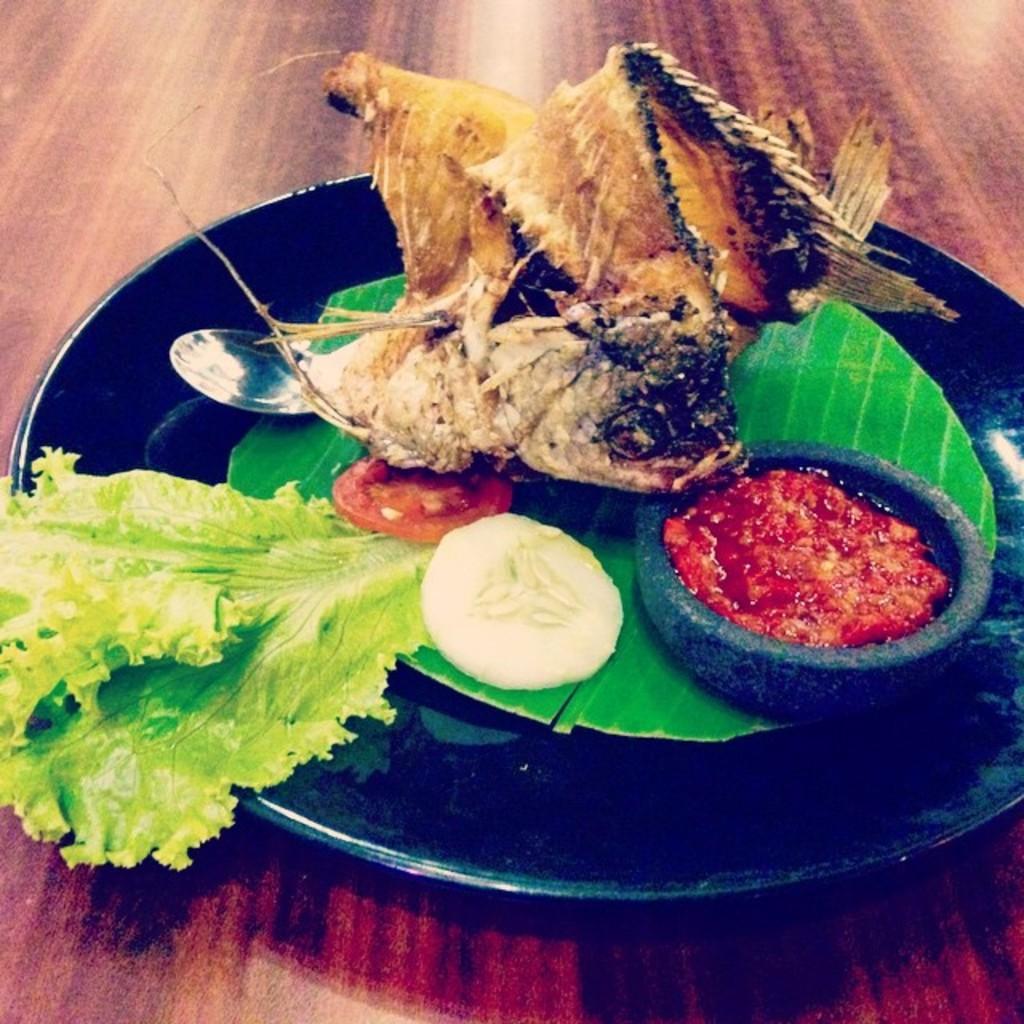Please provide a concise description of this image. In this image there is a table and we can see a plate containing food and a bowl placed on the table. 